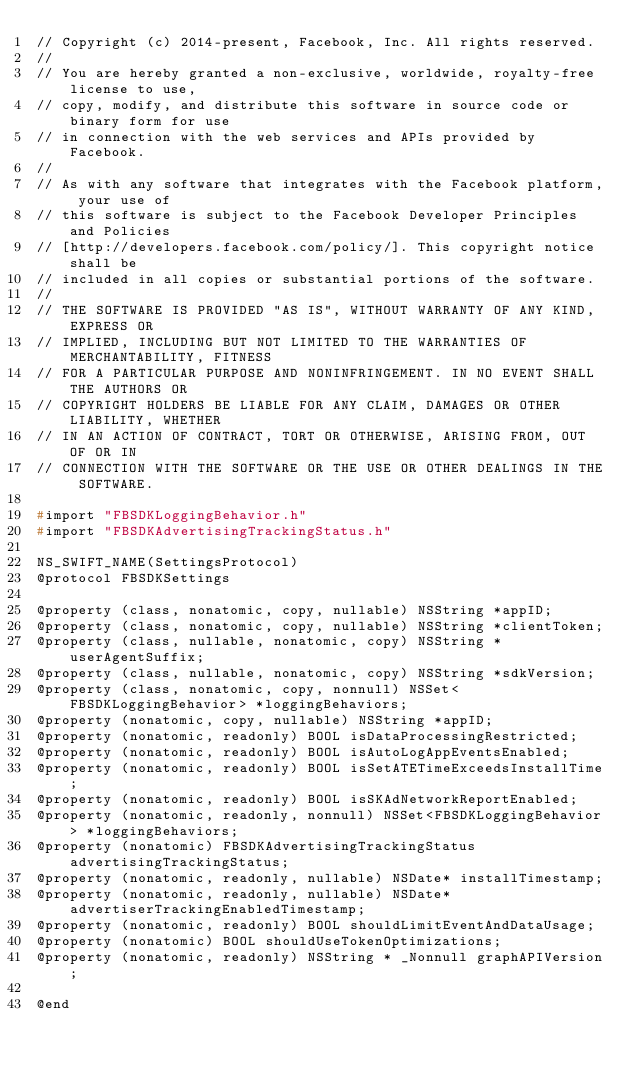<code> <loc_0><loc_0><loc_500><loc_500><_C_>// Copyright (c) 2014-present, Facebook, Inc. All rights reserved.
//
// You are hereby granted a non-exclusive, worldwide, royalty-free license to use,
// copy, modify, and distribute this software in source code or binary form for use
// in connection with the web services and APIs provided by Facebook.
//
// As with any software that integrates with the Facebook platform, your use of
// this software is subject to the Facebook Developer Principles and Policies
// [http://developers.facebook.com/policy/]. This copyright notice shall be
// included in all copies or substantial portions of the software.
//
// THE SOFTWARE IS PROVIDED "AS IS", WITHOUT WARRANTY OF ANY KIND, EXPRESS OR
// IMPLIED, INCLUDING BUT NOT LIMITED TO THE WARRANTIES OF MERCHANTABILITY, FITNESS
// FOR A PARTICULAR PURPOSE AND NONINFRINGEMENT. IN NO EVENT SHALL THE AUTHORS OR
// COPYRIGHT HOLDERS BE LIABLE FOR ANY CLAIM, DAMAGES OR OTHER LIABILITY, WHETHER
// IN AN ACTION OF CONTRACT, TORT OR OTHERWISE, ARISING FROM, OUT OF OR IN
// CONNECTION WITH THE SOFTWARE OR THE USE OR OTHER DEALINGS IN THE SOFTWARE.

#import "FBSDKLoggingBehavior.h"
#import "FBSDKAdvertisingTrackingStatus.h"

NS_SWIFT_NAME(SettingsProtocol)
@protocol FBSDKSettings

@property (class, nonatomic, copy, nullable) NSString *appID;
@property (class, nonatomic, copy, nullable) NSString *clientToken;
@property (class, nullable, nonatomic, copy) NSString *userAgentSuffix;
@property (class, nullable, nonatomic, copy) NSString *sdkVersion;
@property (class, nonatomic, copy, nonnull) NSSet<FBSDKLoggingBehavior> *loggingBehaviors;
@property (nonatomic, copy, nullable) NSString *appID;
@property (nonatomic, readonly) BOOL isDataProcessingRestricted;
@property (nonatomic, readonly) BOOL isAutoLogAppEventsEnabled;
@property (nonatomic, readonly) BOOL isSetATETimeExceedsInstallTime;
@property (nonatomic, readonly) BOOL isSKAdNetworkReportEnabled;
@property (nonatomic, readonly, nonnull) NSSet<FBSDKLoggingBehavior> *loggingBehaviors;
@property (nonatomic) FBSDKAdvertisingTrackingStatus advertisingTrackingStatus;
@property (nonatomic, readonly, nullable) NSDate* installTimestamp;
@property (nonatomic, readonly, nullable) NSDate* advertiserTrackingEnabledTimestamp;
@property (nonatomic, readonly) BOOL shouldLimitEventAndDataUsage;
@property (nonatomic) BOOL shouldUseTokenOptimizations;
@property (nonatomic, readonly) NSString * _Nonnull graphAPIVersion;

@end
</code> 